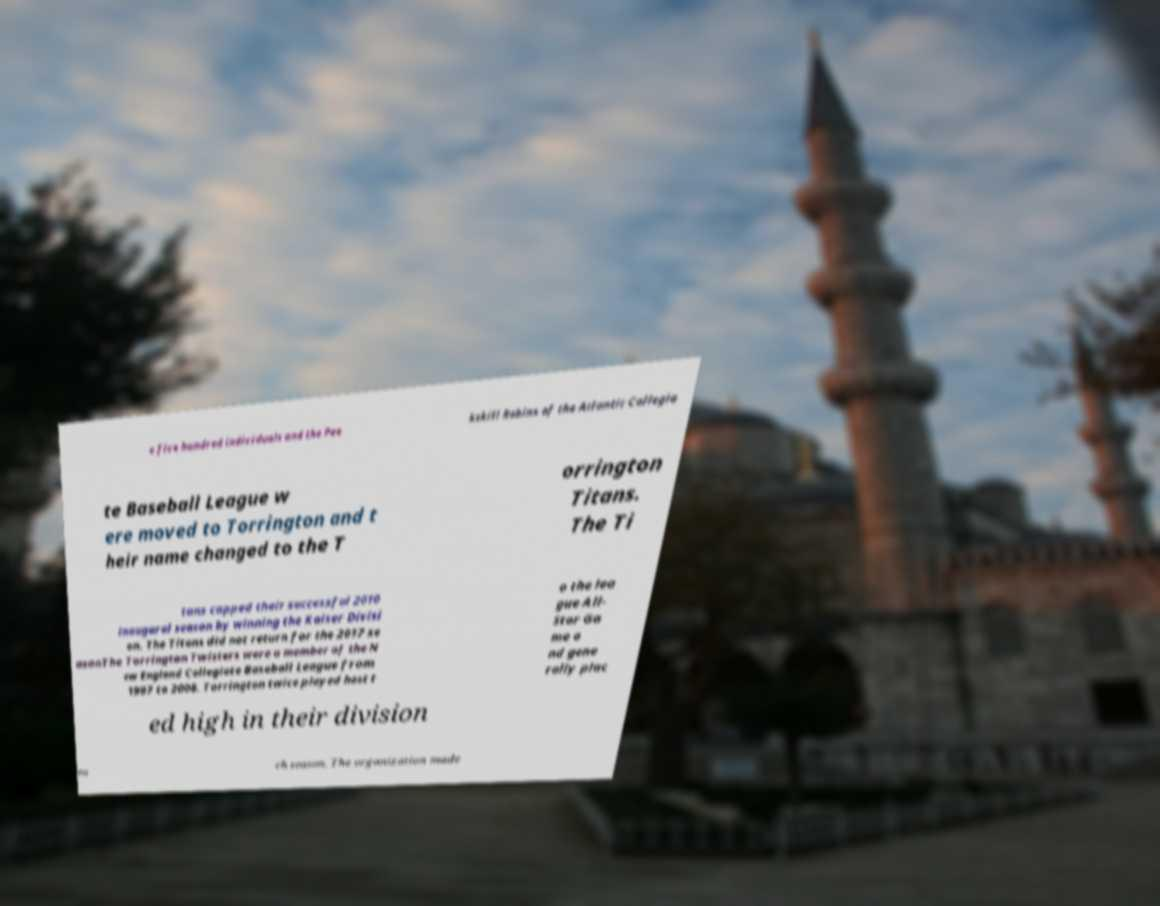Please read and relay the text visible in this image. What does it say? e five hundred individuals and the Pee kskill Robins of the Atlantic Collegia te Baseball League w ere moved to Torrington and t heir name changed to the T orrington Titans. The Ti tans capped their successful 2010 inaugural season by winning the Kaiser Divisi on. The Titans did not return for the 2017 se asonThe Torrington Twisters were a member of the N ew England Collegiate Baseball League from 1997 to 2008. Torrington twice played host t o the lea gue All- Star Ga me a nd gene rally plac ed high in their division ea ch season. The organization made 